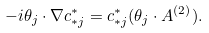<formula> <loc_0><loc_0><loc_500><loc_500>- i \theta _ { j } \cdot \nabla c _ { * j } ^ { * } = c _ { * j } ^ { * } ( \theta _ { j } \cdot A ^ { ( 2 ) } ) .</formula> 